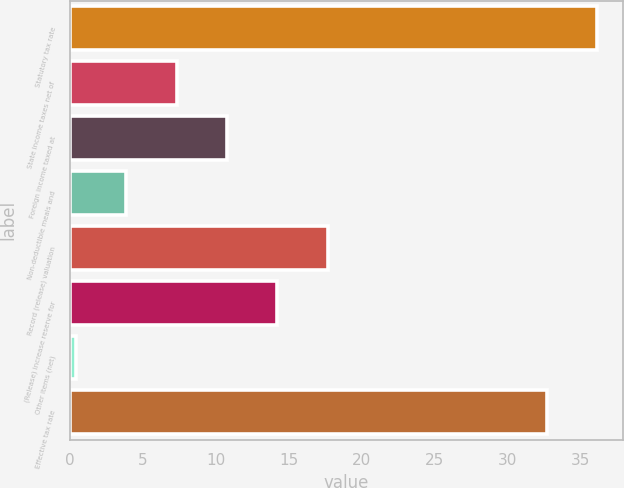<chart> <loc_0><loc_0><loc_500><loc_500><bar_chart><fcel>Statutory tax rate<fcel>State income taxes net of<fcel>Foreign income taxed at<fcel>Non-deductible meals and<fcel>Record (release) valuation<fcel>(Release) increase reserve for<fcel>Other items (net)<fcel>Effective tax rate<nl><fcel>36.16<fcel>7.32<fcel>10.78<fcel>3.86<fcel>17.7<fcel>14.24<fcel>0.4<fcel>32.7<nl></chart> 